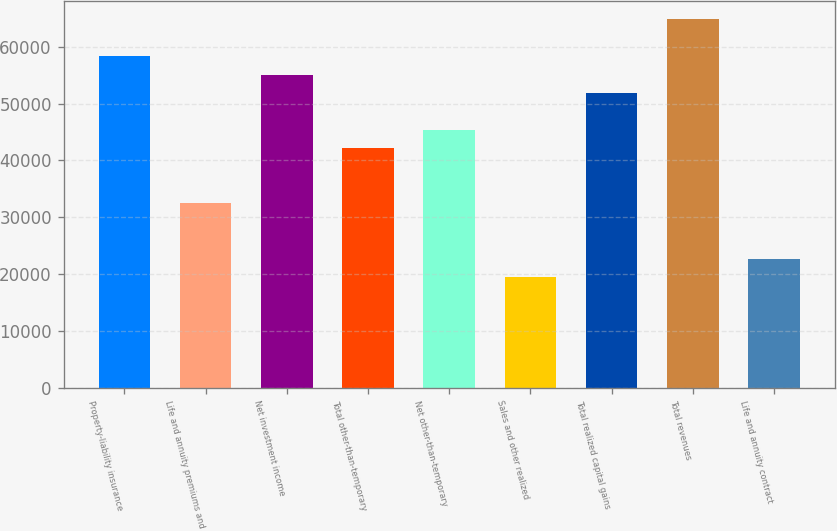<chart> <loc_0><loc_0><loc_500><loc_500><bar_chart><fcel>Property-liability insurance<fcel>Life and annuity premiums and<fcel>Net investment income<fcel>Total other-than-temporary<fcel>Net other-than-temporary<fcel>Sales and other realized<fcel>Total realized capital gains<fcel>Total revenues<fcel>Life and annuity contract<nl><fcel>58338.6<fcel>32413<fcel>55097.9<fcel>42135.1<fcel>45375.8<fcel>19450.2<fcel>51857.2<fcel>64820<fcel>22690.9<nl></chart> 